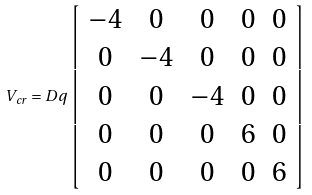Convert formula to latex. <formula><loc_0><loc_0><loc_500><loc_500>V _ { c r } = D q \left [ \begin{array} { c c c c c } - 4 & 0 & 0 & 0 & 0 \\ 0 & - 4 & 0 & 0 & 0 \\ 0 & 0 & - 4 & 0 & 0 \\ 0 & 0 & 0 & 6 & 0 \\ 0 & 0 & 0 & 0 & 6 \end{array} \right ]</formula> 